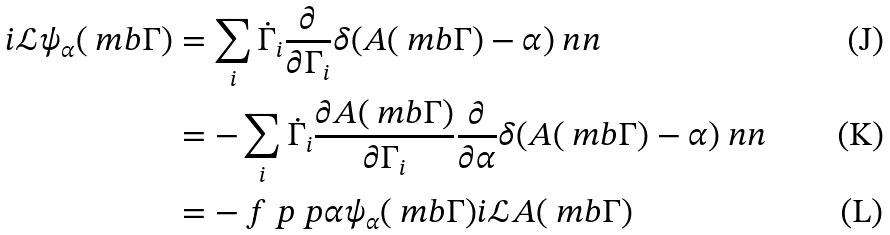<formula> <loc_0><loc_0><loc_500><loc_500>i \mathcal { L } \psi _ { \alpha } ( \ m b \Gamma ) & = \sum _ { i } \dot { \Gamma } _ { i } \frac { \partial } { \partial \Gamma _ { i } } \delta ( A ( \ m b \Gamma ) - \alpha ) \ n n \\ & = - \sum _ { i } \dot { \Gamma } _ { i } \frac { \partial A ( \ m b \Gamma ) } { \partial \Gamma _ { i } } \frac { \partial } { \partial \alpha } \delta ( A ( \ m b \Gamma ) - \alpha ) \ n n \\ & = - \ f { \ p } { \ p \alpha } \psi _ { \alpha } ( \ m b \Gamma ) i \mathcal { L } A ( \ m b \Gamma )</formula> 